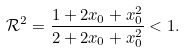Convert formula to latex. <formula><loc_0><loc_0><loc_500><loc_500>\mathcal { R } ^ { 2 } = \frac { 1 + 2 x _ { 0 } + x _ { 0 } ^ { 2 } } { 2 + 2 x _ { 0 } + x _ { 0 } ^ { 2 } } < 1 .</formula> 